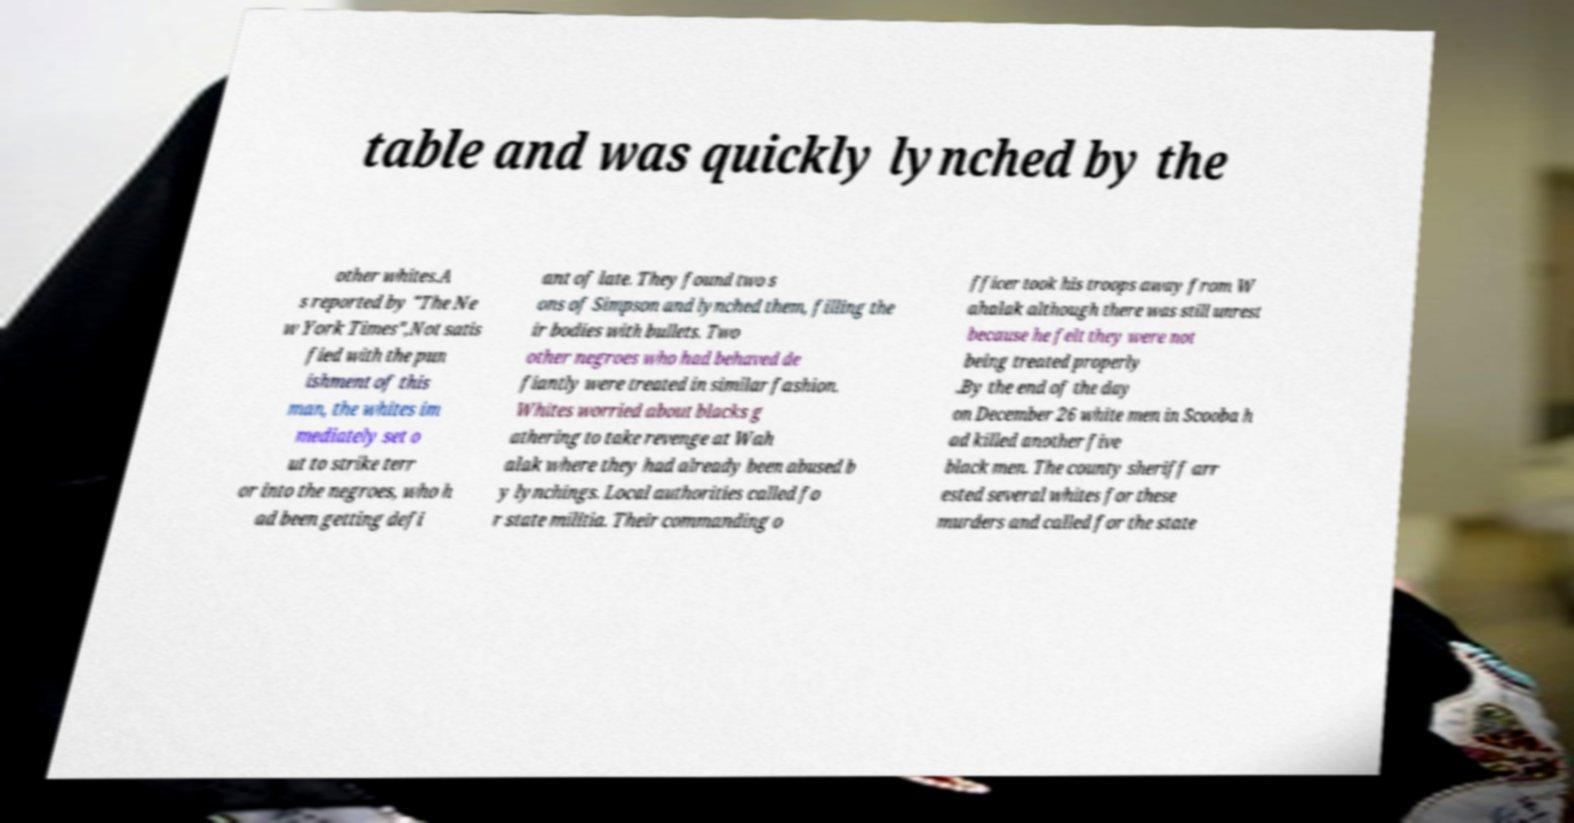There's text embedded in this image that I need extracted. Can you transcribe it verbatim? table and was quickly lynched by the other whites.A s reported by "The Ne w York Times",Not satis fied with the pun ishment of this man, the whites im mediately set o ut to strike terr or into the negroes, who h ad been getting defi ant of late. They found two s ons of Simpson and lynched them, filling the ir bodies with bullets. Two other negroes who had behaved de fiantly were treated in similar fashion. Whites worried about blacks g athering to take revenge at Wah alak where they had already been abused b y lynchings. Local authorities called fo r state militia. Their commanding o fficer took his troops away from W ahalak although there was still unrest because he felt they were not being treated properly .By the end of the day on December 26 white men in Scooba h ad killed another five black men. The county sheriff arr ested several whites for these murders and called for the state 